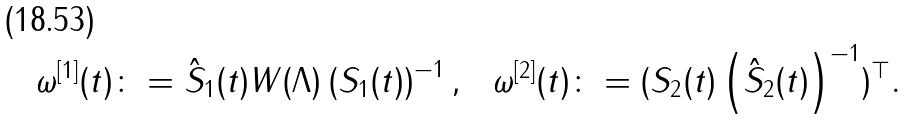<formula> <loc_0><loc_0><loc_500><loc_500>\omega ^ { [ 1 ] } ( t ) & \colon = \hat { S } _ { 1 } ( t ) W ( \Lambda ) \left ( S _ { 1 } ( t ) \right ) ^ { - 1 } , & \omega ^ { [ 2 ] } ( t ) & \colon = ( S _ { 2 } ( t ) \left ( \hat { S } _ { 2 } ( t ) \right ) ^ { - 1 } ) ^ { \top } .</formula> 